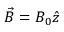<formula> <loc_0><loc_0><loc_500><loc_500>\vec { B } = B _ { 0 } \hat { z }</formula> 